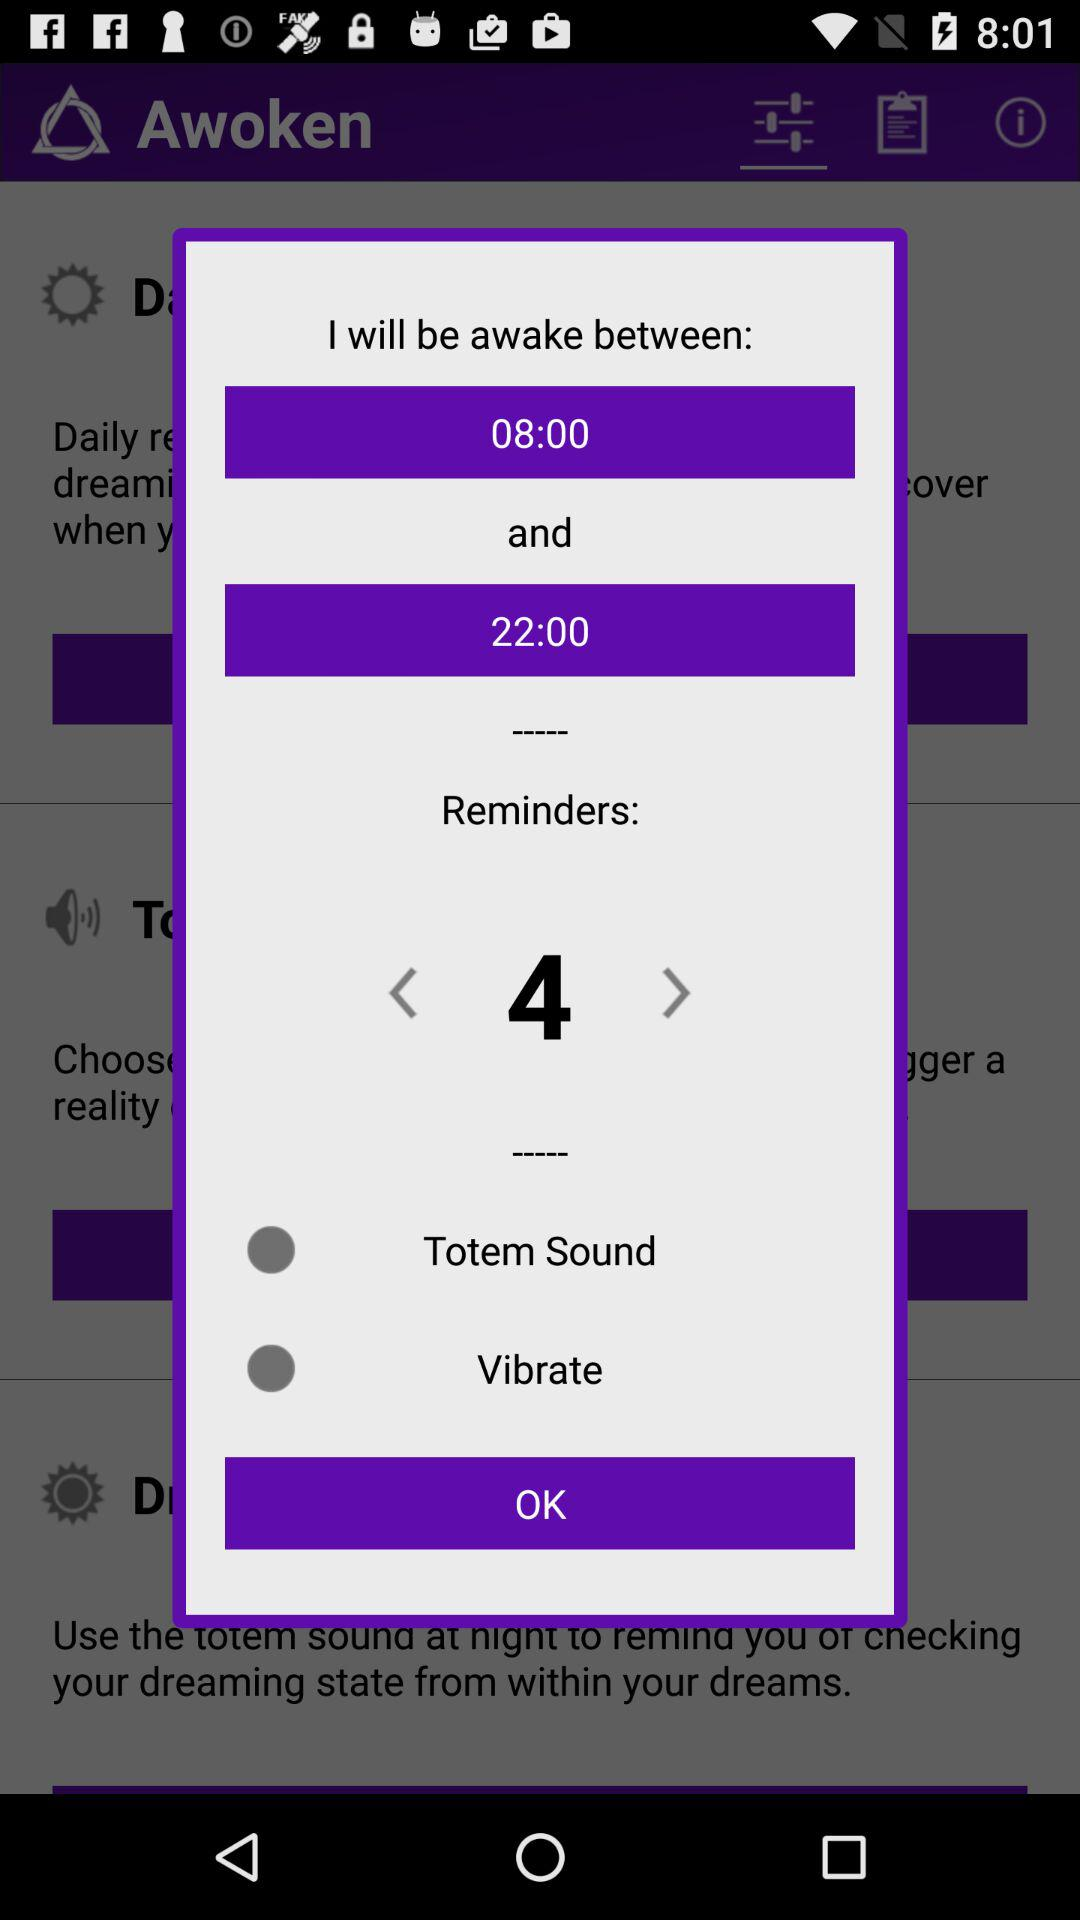What is the awake time? The awake time is between 08:00 and 22:00. 